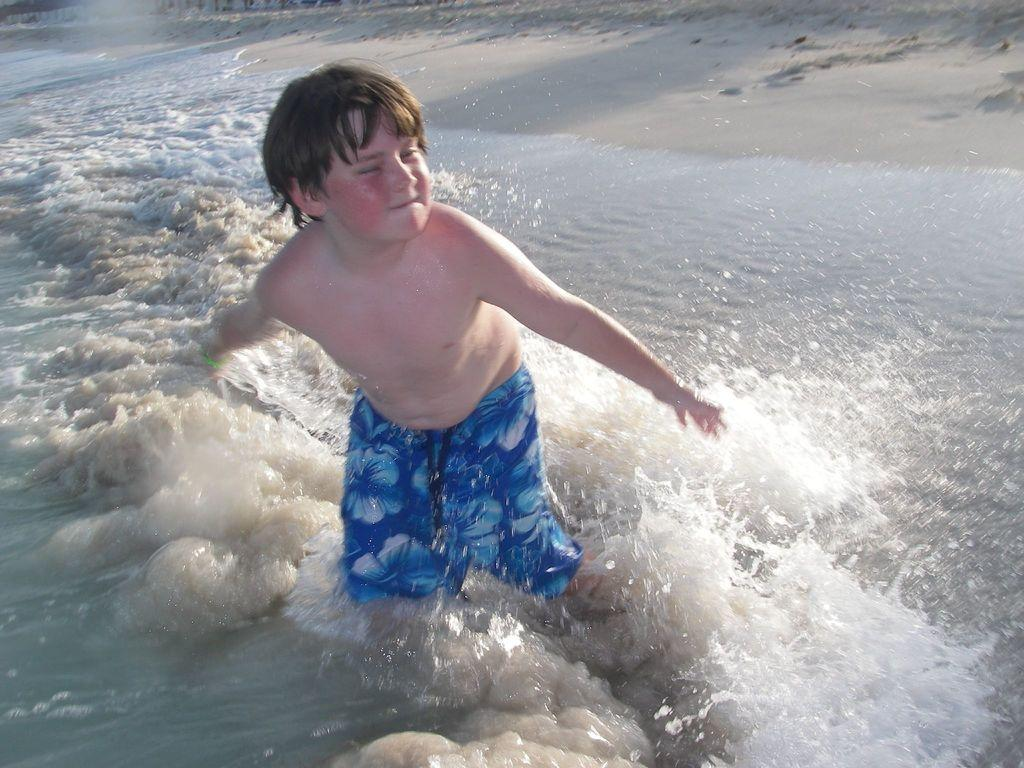What is the main subject of the image? There is a boy standing in the image. What can be seen at the bottom of the image? There is water visible towards the bottom of the image. What is visible at the top of the image? There is sand visible towards the top of the image. What type of ink can be seen in the image? There is no ink present in the image. How does the boy take flight in the image? The boy is not taking flight in the image; he is standing on the ground. 